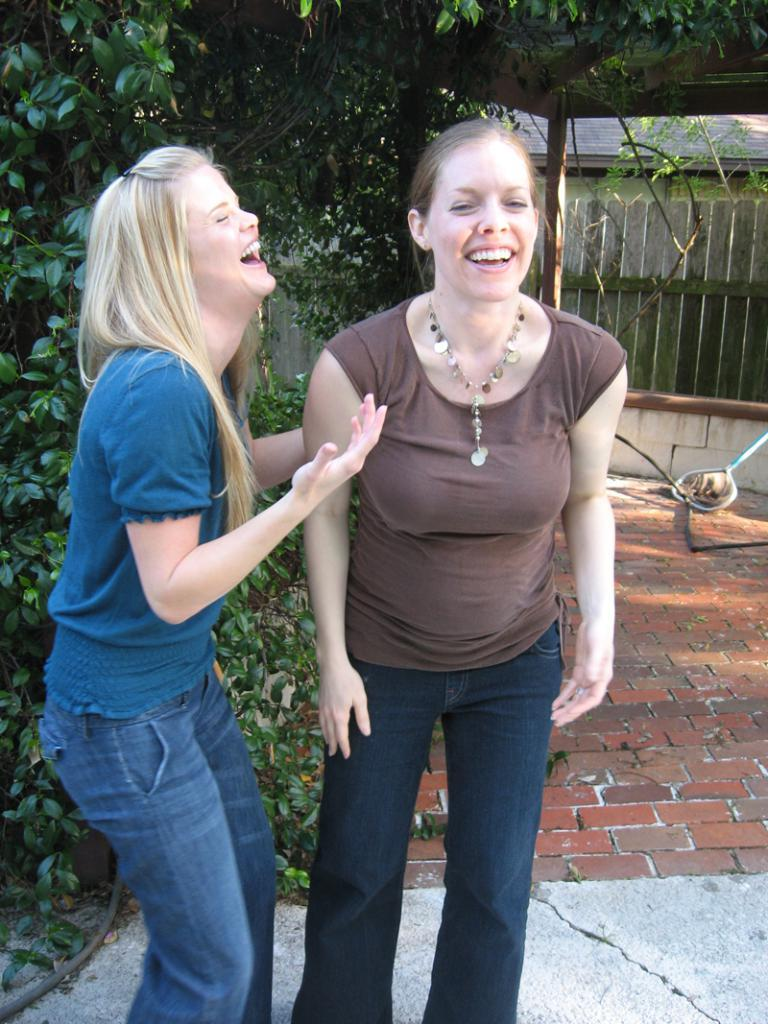How many people are in the image? There are two women in the image. What are the women doing in the image? The women are standing. What can be seen in the background of the image? There are trees in the background of the image. How many spiders are crawling on the women in the image? There are no spiders visible in the image; it only shows two women standing with trees in the background. 